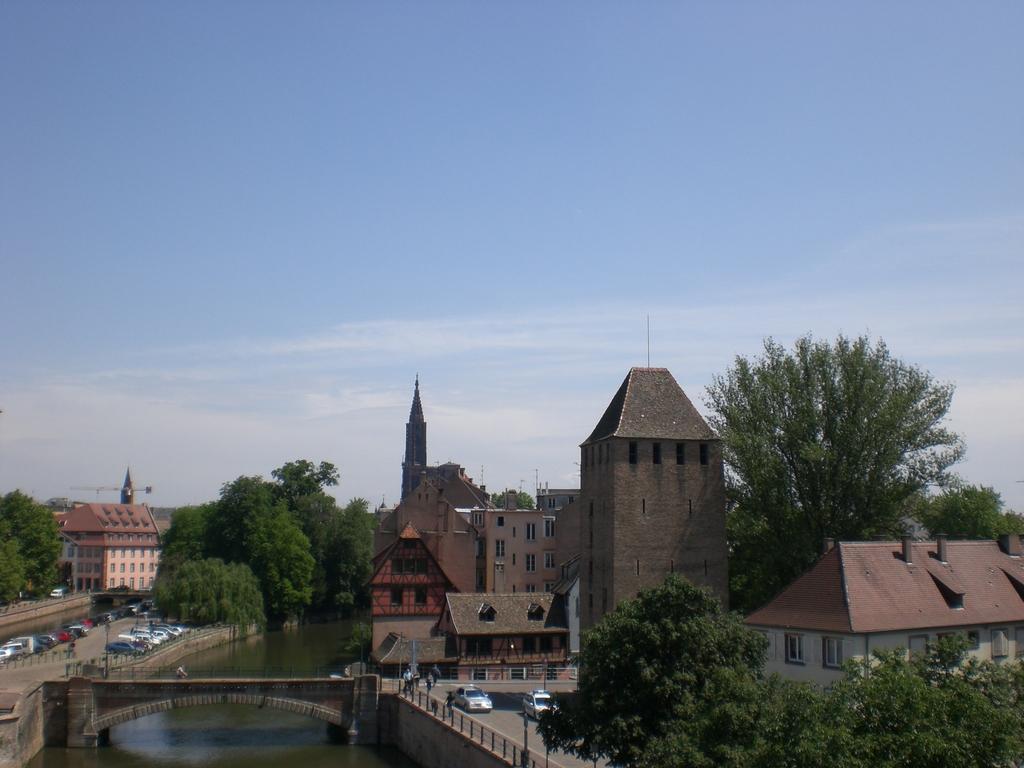In one or two sentences, can you explain what this image depicts? At the bottom there is a bridge and water. On the right we can see buildings and church. On the left there is a crane near to the building. In the bottom left corner we can see many cars which are parked near to the dancing, street lights and road. At the top we can see sky and clouds. 